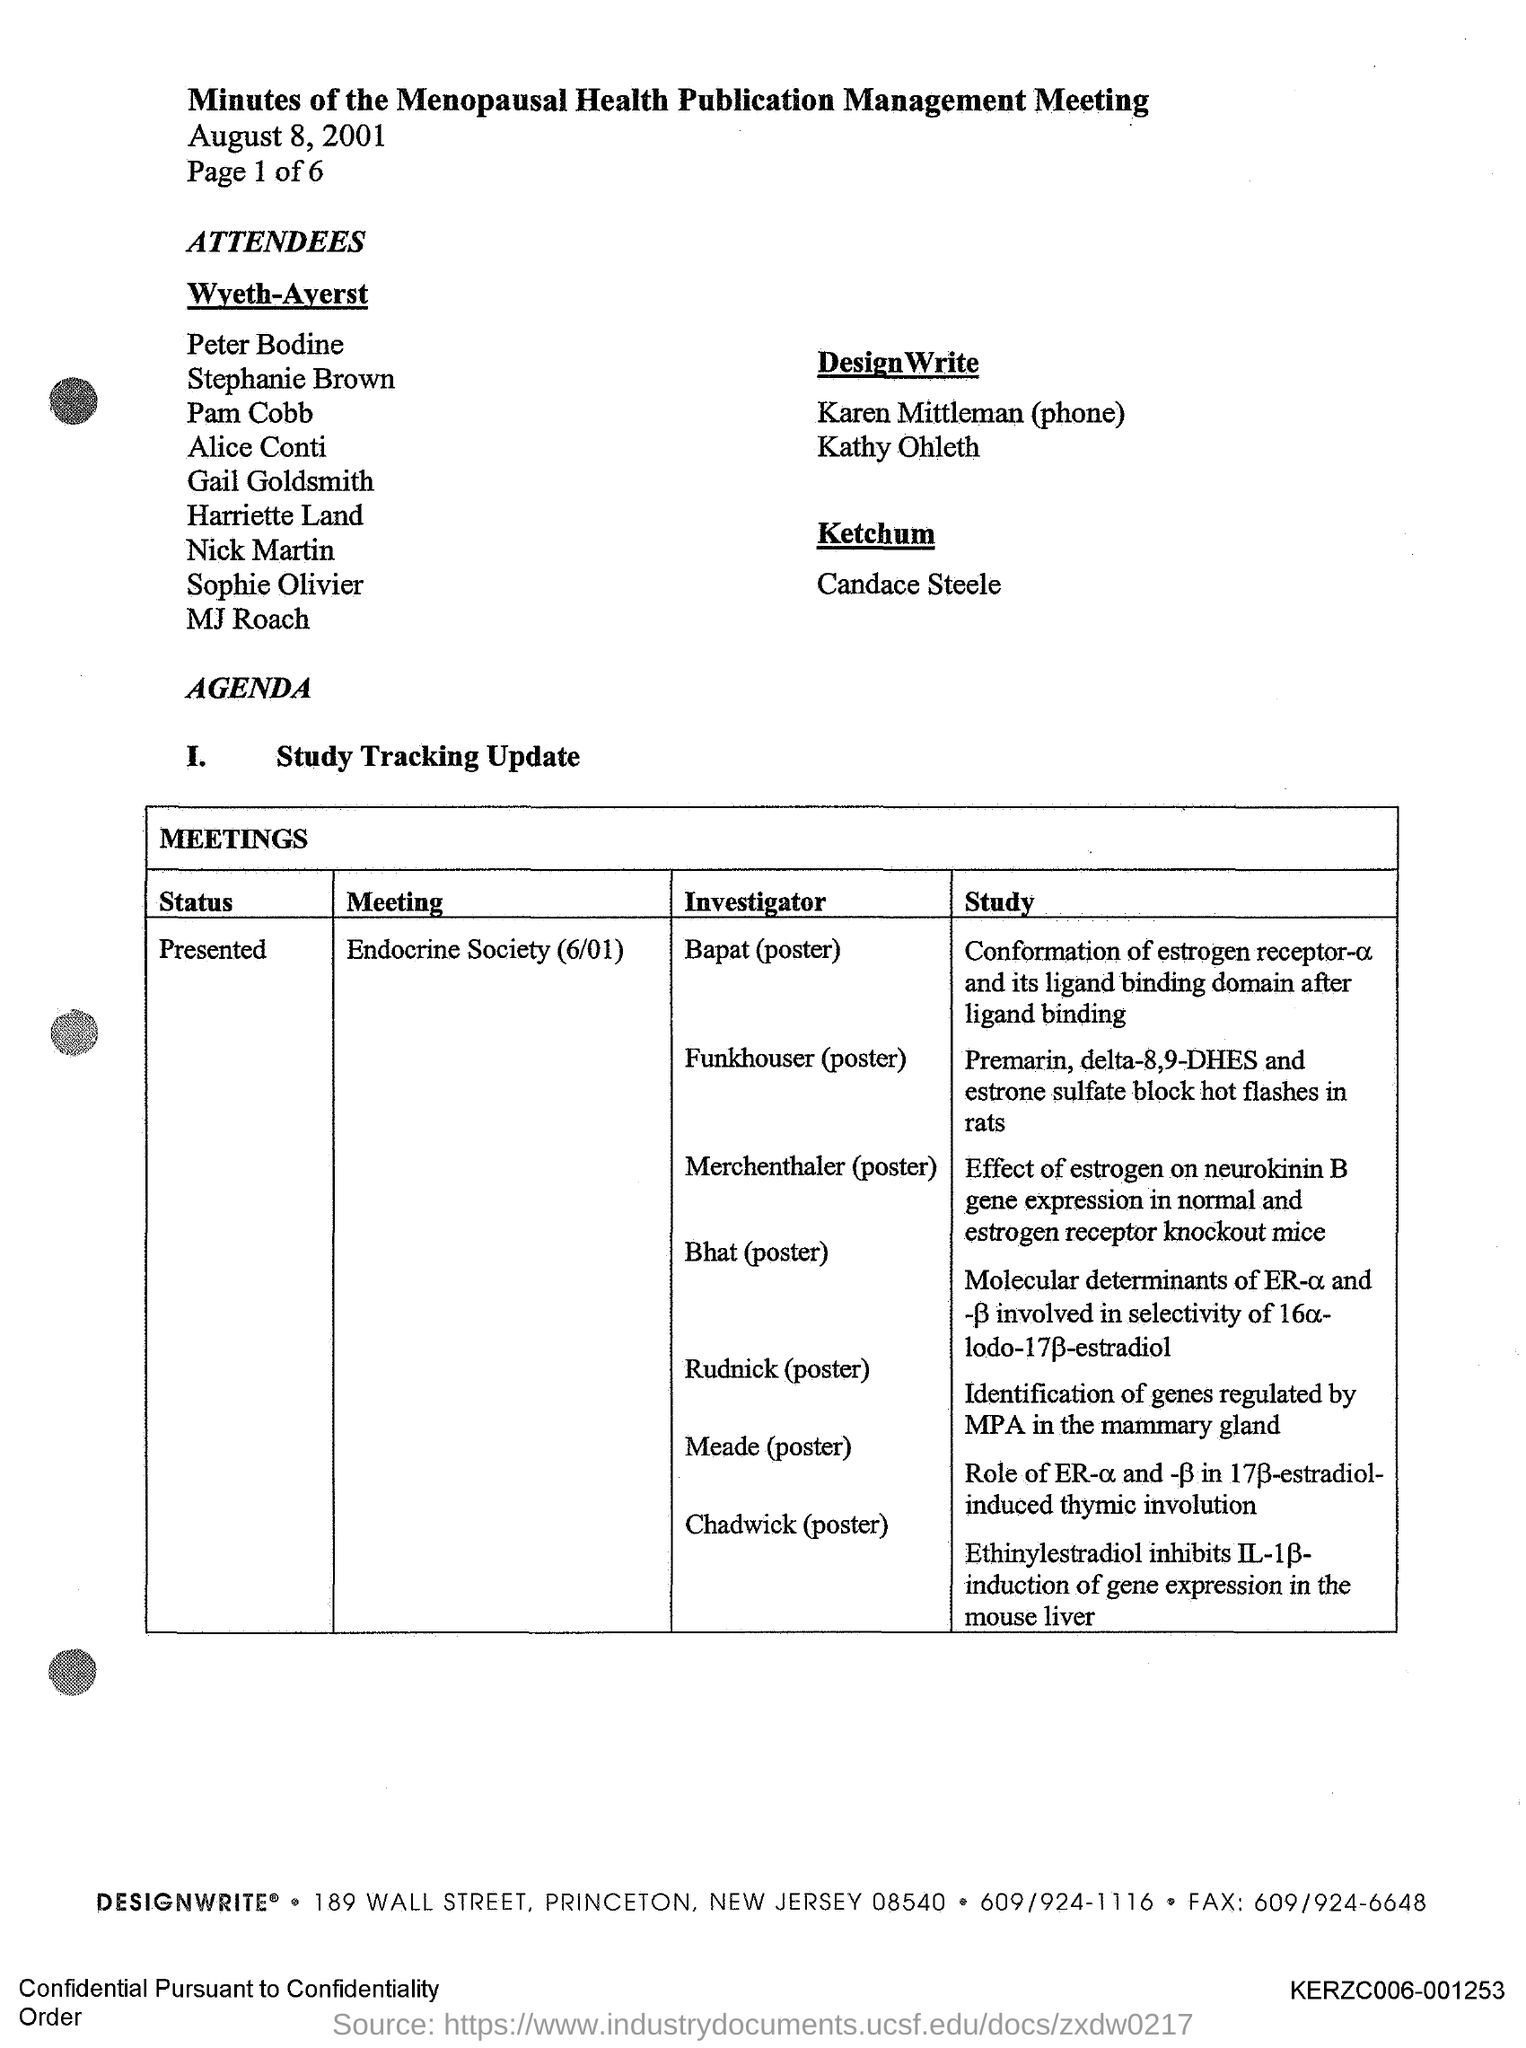What is the title of the document?
Your response must be concise. Minutes of the Menopausal Health Publication Management Meeting. 